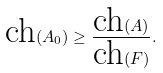Convert formula to latex. <formula><loc_0><loc_0><loc_500><loc_500>\text {ch} ( A _ { 0 } ) \geq \frac { \text {ch} ( A ) } { \text {ch} ( F ) } .</formula> 